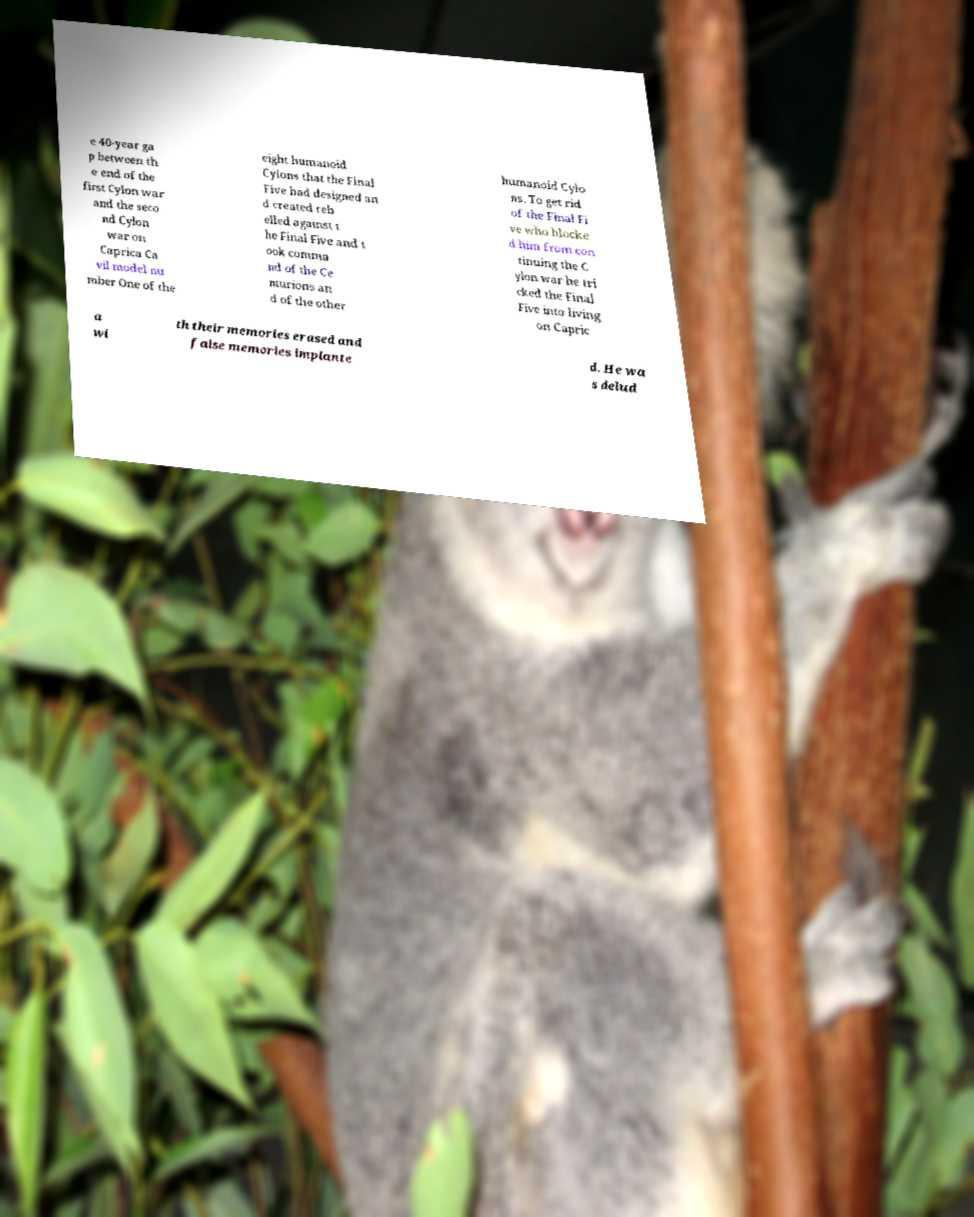Please identify and transcribe the text found in this image. e 40-year ga p between th e end of the first Cylon war and the seco nd Cylon war on Caprica Ca vil model nu mber One of the eight humanoid Cylons that the Final Five had designed an d created reb elled against t he Final Five and t ook comma nd of the Ce nturions an d of the other humanoid Cylo ns. To get rid of the Final Fi ve who blocke d him from con tinuing the C ylon war he tri cked the Final Five into living on Capric a wi th their memories erased and false memories implante d. He wa s delud 